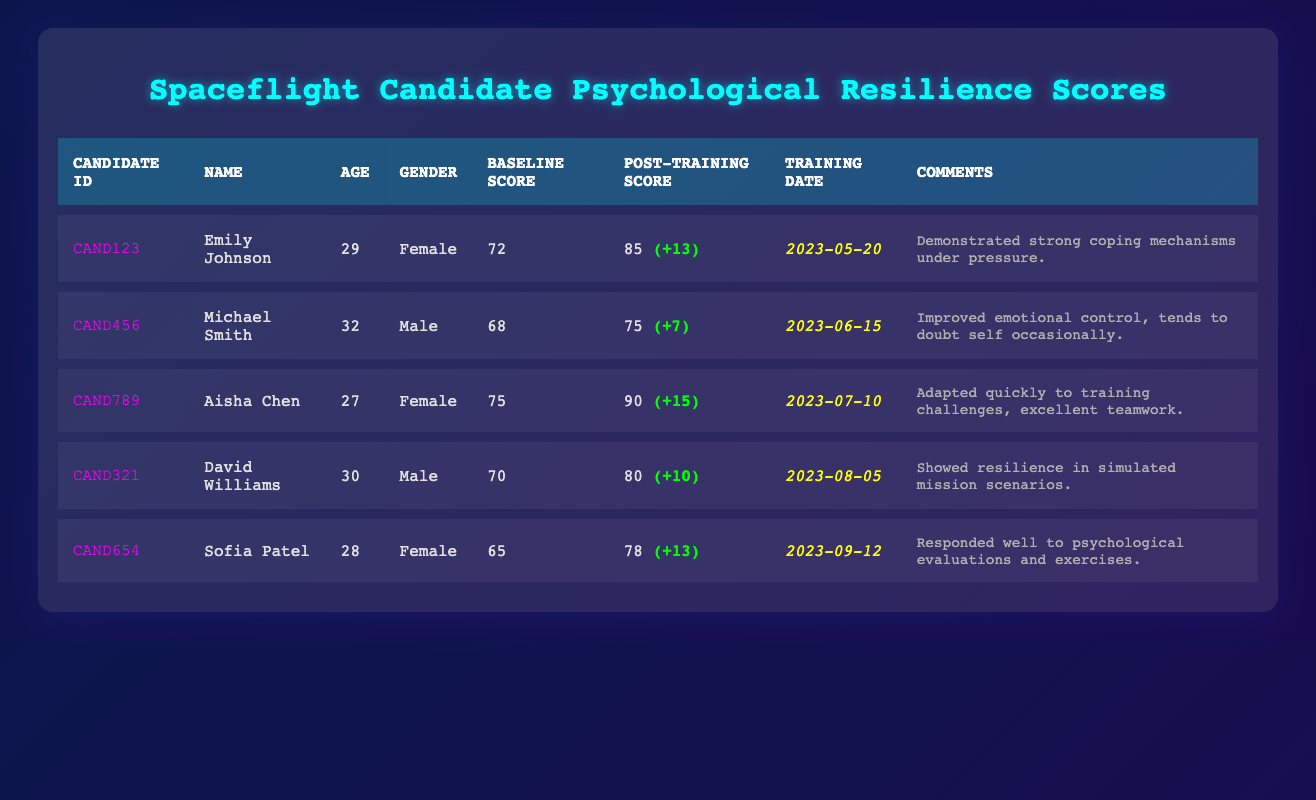What is the name of the candidate with the highest Post-Training Score? The table shows that Aisha Chen has the highest Post-Training Score of 90. By looking through each row for the highest value in the "Post-Training Score" column, Aisha Chen's name corresponds to this value.
Answer: Aisha Chen What was Emily Johnson's Baseline Score? Looking at the row for Emily Johnson, the Baseline Score is clearly listed as 72. This is a direct retrieval from the "Baseline Score" column in her respective row.
Answer: 72 How much did Michael Smith improve after the training? The Post-Training Score for Michael Smith is 75, and his Baseline Score is 68. To find the improvement, we subtract the Baseline Score from the Post-Training Score (75 - 68), which gives us an improvement of 7.
Answer: 7 Is there a candidate who demonstrated excellent teamwork? According to the comments in the table, Aisha Chen is noted for "excellent teamwork." Thus, this statement is true. We refer to the "Comments" column for confirmation on this attribute related to Aisha.
Answer: Yes What is the average Baseline Score of all candidates? To calculate the average Baseline Score, we sum the Baseline Scores of all candidates (72 + 68 + 75 + 70 + 65 = 350). Then, we divide by the number of candidates, which is 5. The average is 350 / 5 = 70.
Answer: 70 Which candidate had the lowest Baseline Score? The Baseline Scores are as follows: 72, 68, 75, 70, and 65. The lowest score is 65, which corresponds to Sofia Patel. We identify the candidate with the minimum value in the "Baseline Score" column.
Answer: Sofia Patel Did David Williams improve more than 10 points after the training? David Williams had a Baseline Score of 70 and a Post-Training Score of 80. The improvement is calculated as (80 - 70 = 10). Since 10 points is not greater than 10, the answer is no.
Answer: No What is the training date for Sofia Patel? Looking at the row corresponding to Sofia Patel, the Training Date is provided as 2023-09-12. This is directly retrieved from the "Training Date" column in her row.
Answer: 2023-09-12 Which candidate had a Baseline Score above 70 and a Post-Training Score of 80 or more? We evaluate each candidate: Emily Johnson's scores are above those thresholds, and so are Aisha Chen's. We refer to both the "Baseline Score" and "Post-Training Score" columns to validate this point for each candidate.
Answer: Emily Johnson and Aisha Chen 